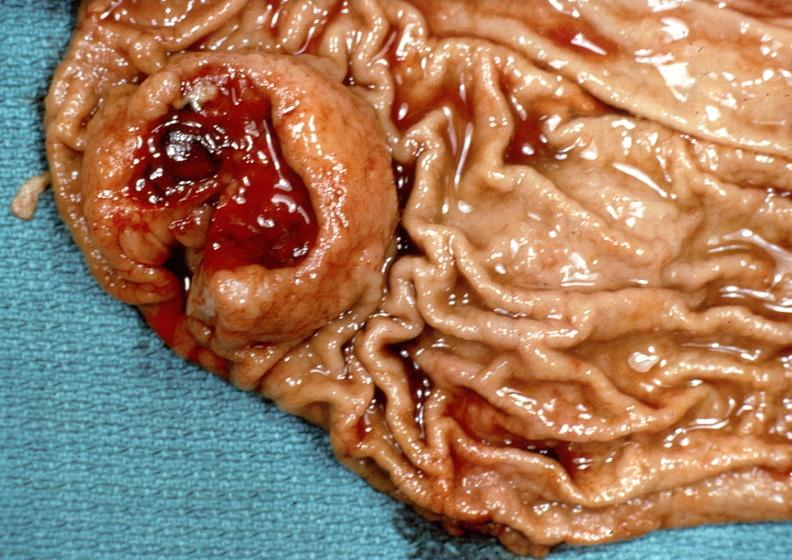does this image show stomach?
Answer the question using a single word or phrase. Yes 